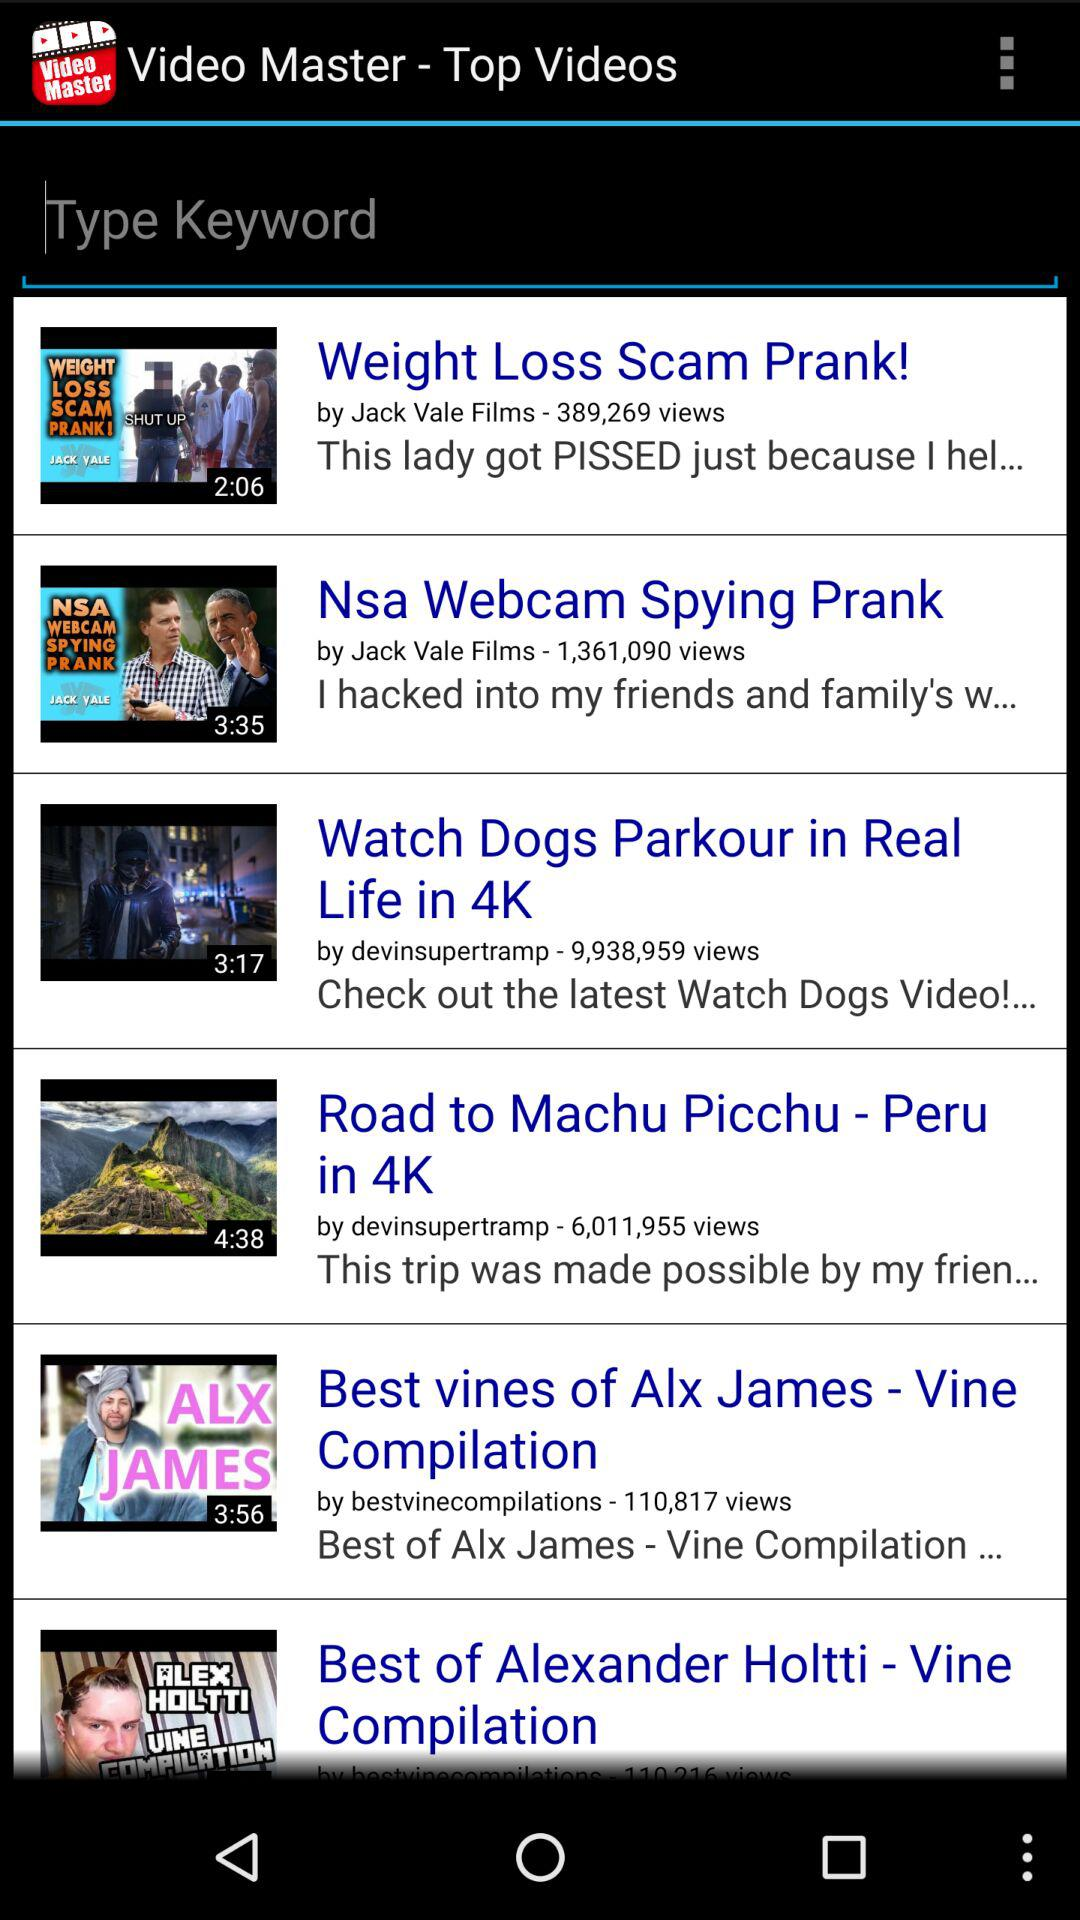How many views are there on "Nsa Webcam Spying Prank"? There are 1,361,090 views. 